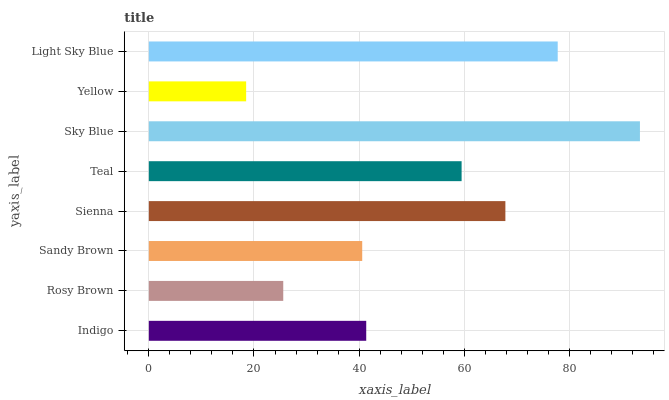Is Yellow the minimum?
Answer yes or no. Yes. Is Sky Blue the maximum?
Answer yes or no. Yes. Is Rosy Brown the minimum?
Answer yes or no. No. Is Rosy Brown the maximum?
Answer yes or no. No. Is Indigo greater than Rosy Brown?
Answer yes or no. Yes. Is Rosy Brown less than Indigo?
Answer yes or no. Yes. Is Rosy Brown greater than Indigo?
Answer yes or no. No. Is Indigo less than Rosy Brown?
Answer yes or no. No. Is Teal the high median?
Answer yes or no. Yes. Is Indigo the low median?
Answer yes or no. Yes. Is Indigo the high median?
Answer yes or no. No. Is Sandy Brown the low median?
Answer yes or no. No. 